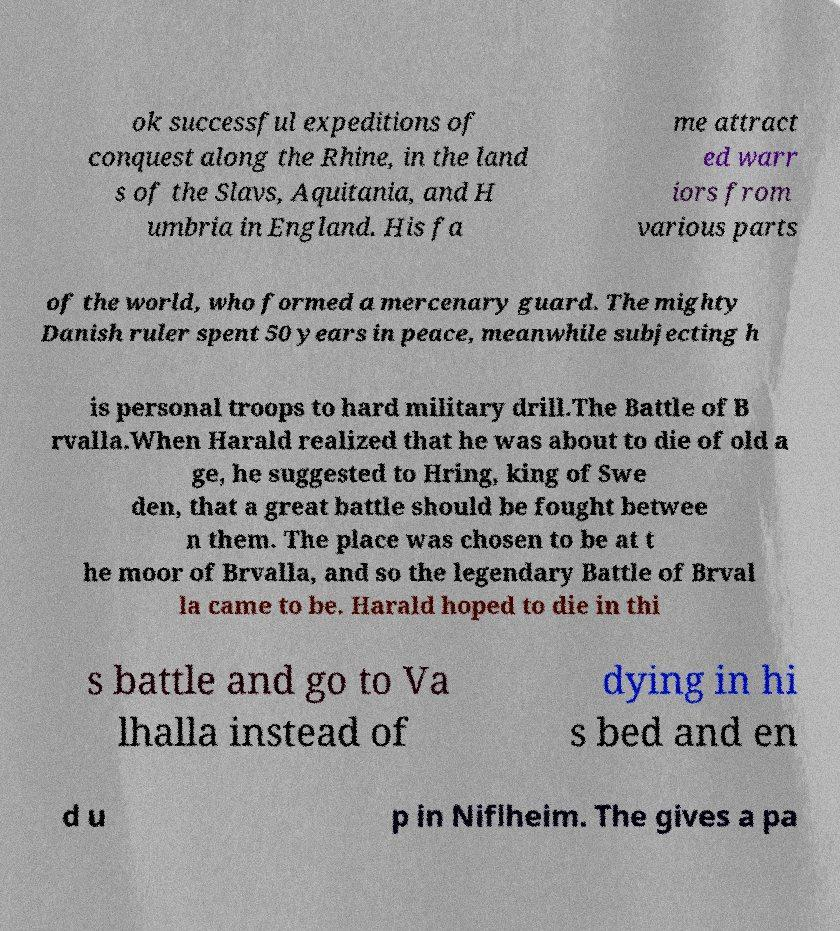Please read and relay the text visible in this image. What does it say? ok successful expeditions of conquest along the Rhine, in the land s of the Slavs, Aquitania, and H umbria in England. His fa me attract ed warr iors from various parts of the world, who formed a mercenary guard. The mighty Danish ruler spent 50 years in peace, meanwhile subjecting h is personal troops to hard military drill.The Battle of B rvalla.When Harald realized that he was about to die of old a ge, he suggested to Hring, king of Swe den, that a great battle should be fought betwee n them. The place was chosen to be at t he moor of Brvalla, and so the legendary Battle of Brval la came to be. Harald hoped to die in thi s battle and go to Va lhalla instead of dying in hi s bed and en d u p in Niflheim. The gives a pa 